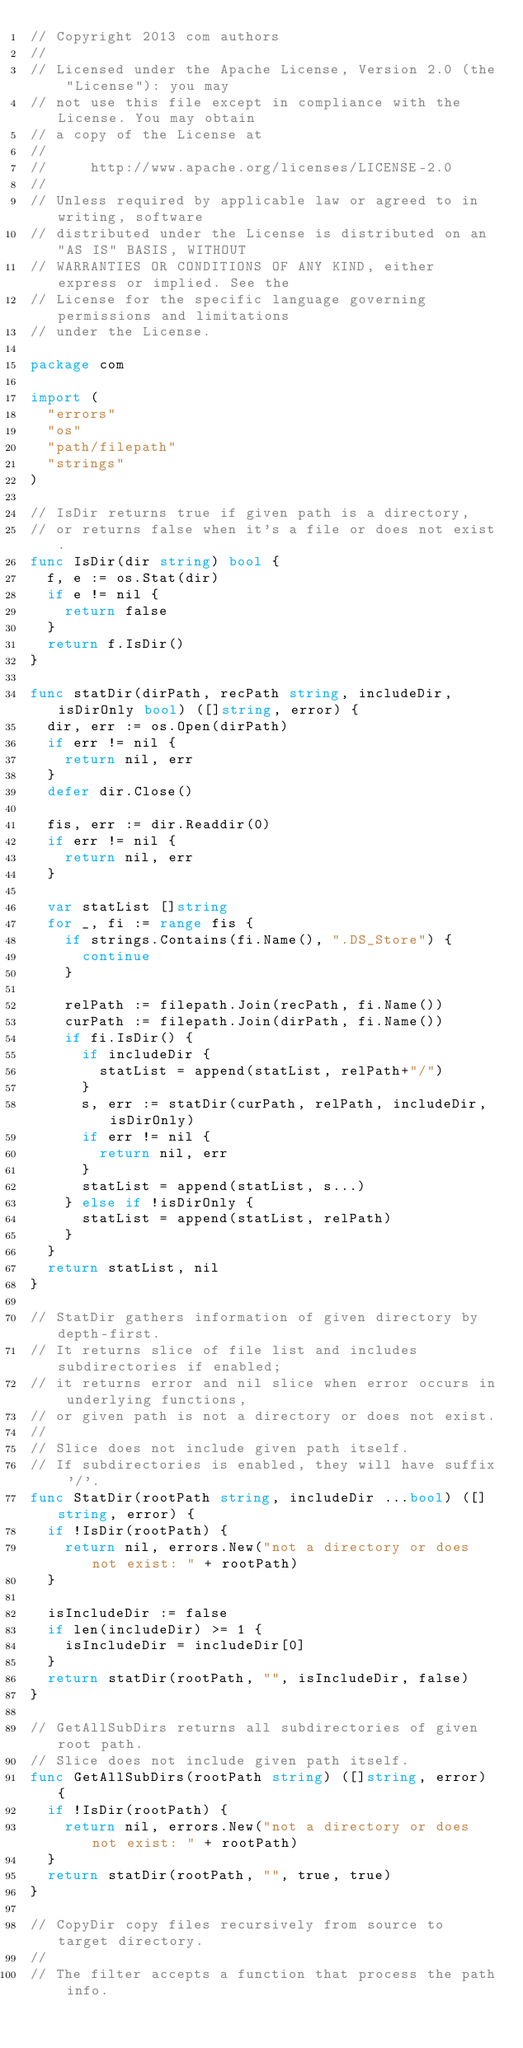Convert code to text. <code><loc_0><loc_0><loc_500><loc_500><_Go_>// Copyright 2013 com authors
//
// Licensed under the Apache License, Version 2.0 (the "License"): you may
// not use this file except in compliance with the License. You may obtain
// a copy of the License at
//
//     http://www.apache.org/licenses/LICENSE-2.0
//
// Unless required by applicable law or agreed to in writing, software
// distributed under the License is distributed on an "AS IS" BASIS, WITHOUT
// WARRANTIES OR CONDITIONS OF ANY KIND, either express or implied. See the
// License for the specific language governing permissions and limitations
// under the License.

package com

import (
	"errors"
	"os"
	"path/filepath"
	"strings"
)

// IsDir returns true if given path is a directory,
// or returns false when it's a file or does not exist.
func IsDir(dir string) bool {
	f, e := os.Stat(dir)
	if e != nil {
		return false
	}
	return f.IsDir()
}

func statDir(dirPath, recPath string, includeDir, isDirOnly bool) ([]string, error) {
	dir, err := os.Open(dirPath)
	if err != nil {
		return nil, err
	}
	defer dir.Close()

	fis, err := dir.Readdir(0)
	if err != nil {
		return nil, err
	}

	var statList []string
	for _, fi := range fis {
		if strings.Contains(fi.Name(), ".DS_Store") {
			continue
		}

		relPath := filepath.Join(recPath, fi.Name())
		curPath := filepath.Join(dirPath, fi.Name())
		if fi.IsDir() {
			if includeDir {
				statList = append(statList, relPath+"/")
			}
			s, err := statDir(curPath, relPath, includeDir, isDirOnly)
			if err != nil {
				return nil, err
			}
			statList = append(statList, s...)
		} else if !isDirOnly {
			statList = append(statList, relPath)
		}
	}
	return statList, nil
}

// StatDir gathers information of given directory by depth-first.
// It returns slice of file list and includes subdirectories if enabled;
// it returns error and nil slice when error occurs in underlying functions,
// or given path is not a directory or does not exist.
//
// Slice does not include given path itself.
// If subdirectories is enabled, they will have suffix '/'.
func StatDir(rootPath string, includeDir ...bool) ([]string, error) {
	if !IsDir(rootPath) {
		return nil, errors.New("not a directory or does not exist: " + rootPath)
	}

	isIncludeDir := false
	if len(includeDir) >= 1 {
		isIncludeDir = includeDir[0]
	}
	return statDir(rootPath, "", isIncludeDir, false)
}

// GetAllSubDirs returns all subdirectories of given root path.
// Slice does not include given path itself.
func GetAllSubDirs(rootPath string) ([]string, error) {
	if !IsDir(rootPath) {
		return nil, errors.New("not a directory or does not exist: " + rootPath)
	}
	return statDir(rootPath, "", true, true)
}

// CopyDir copy files recursively from source to target directory.
//
// The filter accepts a function that process the path info.</code> 